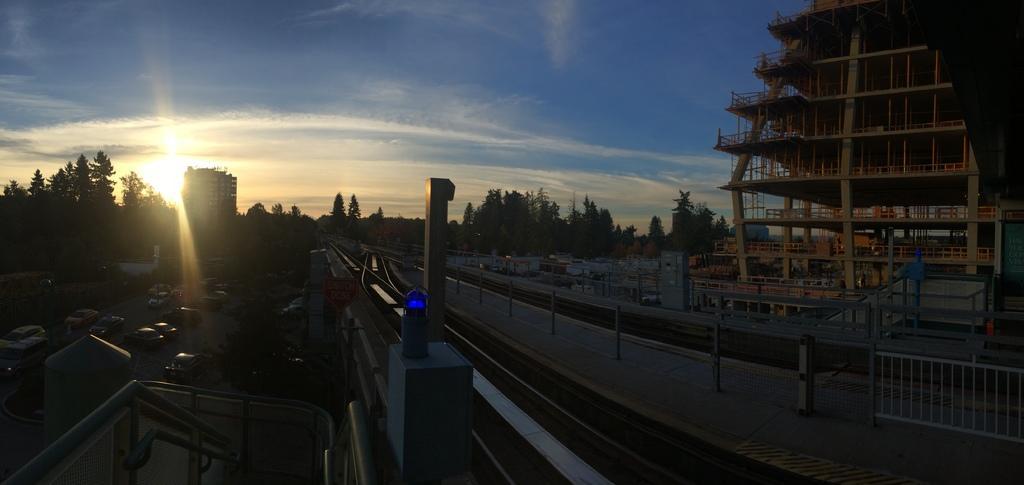Can you describe this image briefly? In this picture there are cars on the left side of the image and there are buildings on the right side of the image and there trees in the center of the image. 